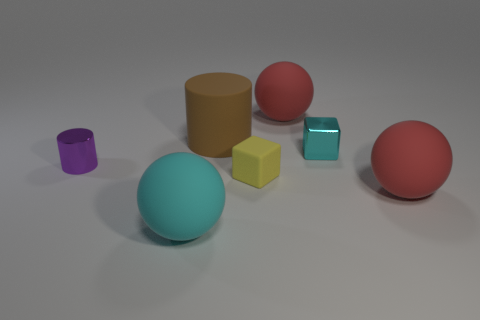What color is the other object that is the same shape as the brown matte object?
Offer a very short reply. Purple. The thing that is in front of the yellow object and left of the brown thing is made of what material?
Give a very brief answer. Rubber. There is a cyan object left of the big brown cylinder; does it have the same shape as the large matte object that is behind the big brown thing?
Provide a succinct answer. Yes. There is a large matte thing that is the same color as the small metallic cube; what shape is it?
Offer a very short reply. Sphere. How many things are red matte objects in front of the big brown rubber cylinder or brown cylinders?
Offer a very short reply. 2. Is the size of the purple cylinder the same as the matte block?
Offer a very short reply. Yes. There is a big object to the right of the small cyan object; what is its color?
Offer a terse response. Red. What size is the yellow block that is the same material as the brown cylinder?
Your answer should be very brief. Small. There is a brown object; is its size the same as the red matte sphere in front of the tiny yellow block?
Ensure brevity in your answer.  Yes. What is the material of the red sphere that is to the left of the cyan metallic thing?
Keep it short and to the point. Rubber. 